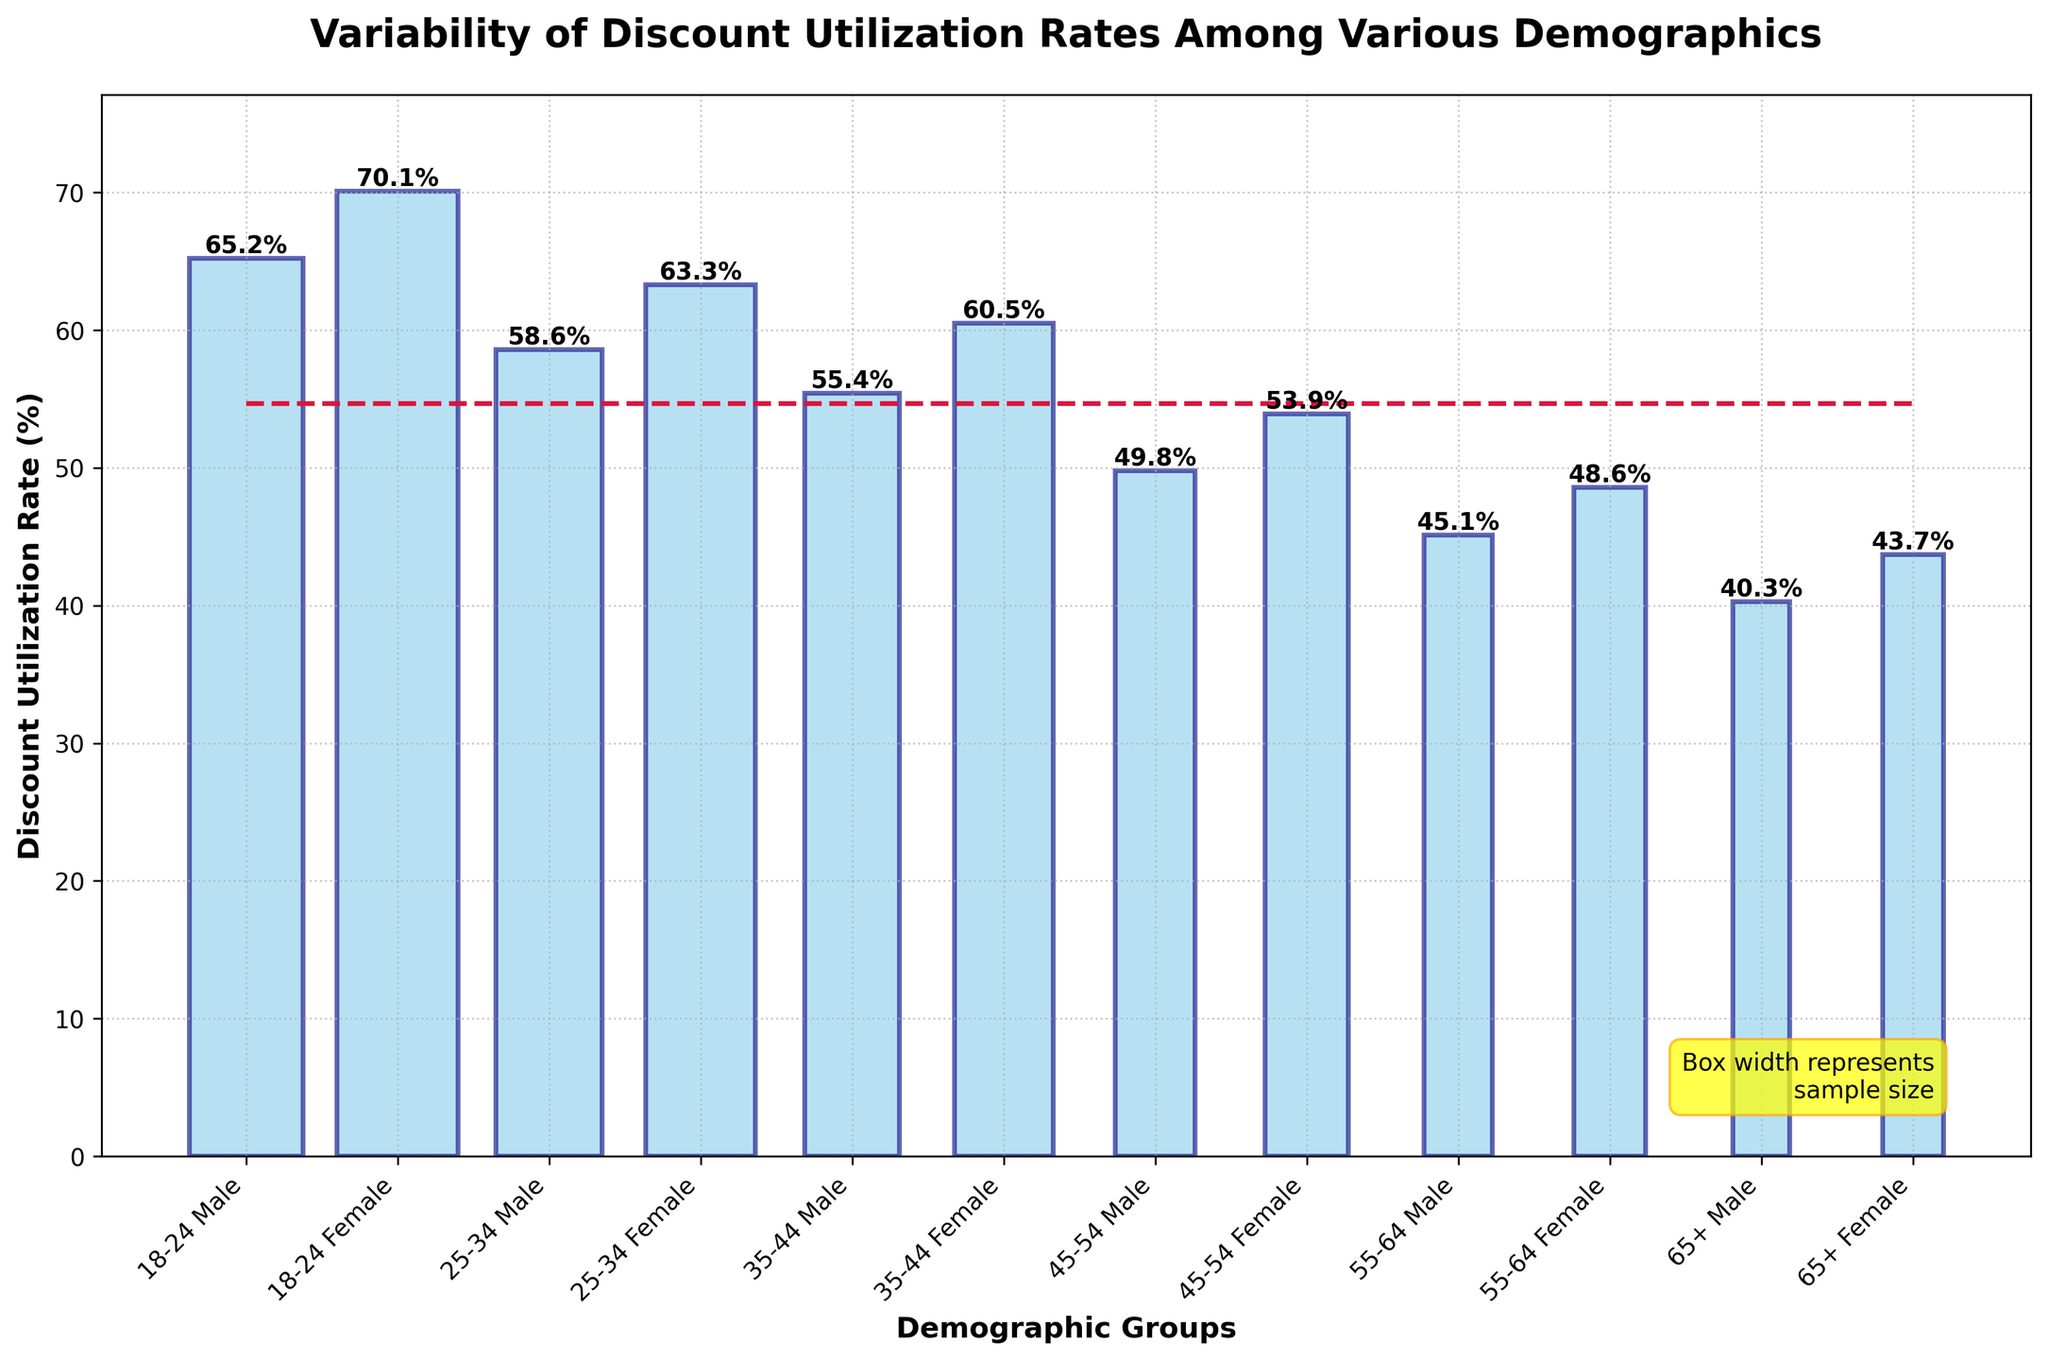What's the title of the figure? The title is at the top of the plot and provides a brief description of what the figure represents.
Answer: Variability of Discount Utilization Rates Among Various Demographics Which demographic group has the highest discount utilization rate? Look at the bar heights for each demographic, the highest bar indicates the highest rate.
Answer: 18-24 Female What is the median discount utilization rate across all demographics? The median rate is indicated by a horizontal dashed line in the figure.
Answer: 53.9% Which demographic group has the lowest discount utilization rate? Look for the demographic with the shortest bar.
Answer: 65+ Male What can you infer about the sample sizes for each group based on the bar widths? The width of each bar represents the sample size; wider bars indicate larger sample sizes, and narrower bars indicate smaller sample sizes.
Answer: Wider bars have larger sample sizes How does the discount utilization rate of 25-34 Female compare to 35-44 Female? Compare the heights of the bars for each demographic group directly.
Answer: 25-34 Female has a higher rate Which demographic shows the largest difference in discount utilization rate between males and females? Calculate the difference in bar heights for each demographic group and compare. 18-24: 70.1 - 65.2 = 4.9, 25-34: 63.3 - 58.6 = 4.7, 35-44: 60.5 - 55.4 = 5.1, 45-54: 53.9 - 49.8 = 4.1, 55-64: 48.6 - 45.1 = 3.5, 65+: 43.7 - 40.3 = 3.4
Answer: 35-44 What is the discount utilization rate range (difference between the highest and lowest rates) across all demographics? Identify the highest and lowest rates and compute the difference. Highest (18-24 Female): 70.1, Lowest (65+ Male): 40.3, so the range is 70.1 - 40.3
Answer: 29.8 Is there a general trend in discount utilization rates as age increases? Observe the pattern in bar heights from younger to older age demographics.
Answer: Generally decreases What's the discount utilization rate difference between the youngest and oldest female groups? Subtract the rate of the oldest female group from the youngest female group. Youngest (18-24 Female): 70.1, Oldest (65+ Female): 43.7, so, 70.1 - 43.7
Answer: 26.4 What does the blue color in the boxes represent? Since it’s a box plot, the color usually represents the bars themselves which indicate the discount utilization rate for each demographic
Answer: Discount Utilization Rate 